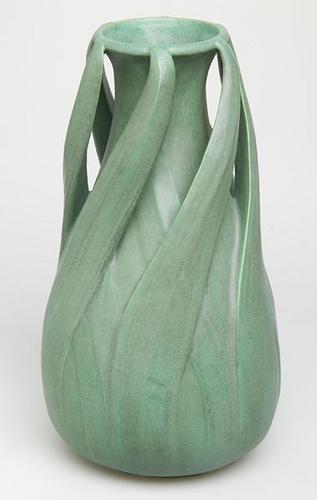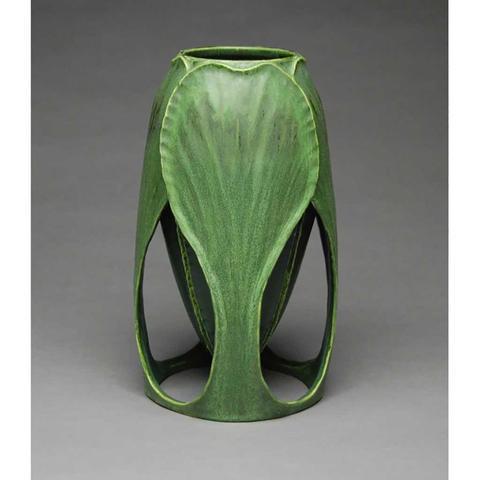The first image is the image on the left, the second image is the image on the right. Considering the images on both sides, is "In one image, a tall vase has an intricate faded green and yellow design with thin vertical elements running top to bottom, accented with small orange fan shapes." valid? Answer yes or no. No. 